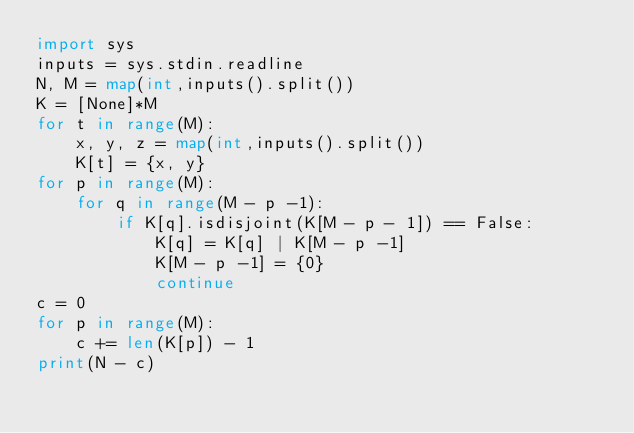<code> <loc_0><loc_0><loc_500><loc_500><_Python_>import sys
inputs = sys.stdin.readline
N, M = map(int,inputs().split())
K = [None]*M
for t in range(M):
	x, y, z = map(int,inputs().split())
	K[t] = {x, y}
for p in range(M):
	for q in range(M - p -1):
		if K[q].isdisjoint(K[M - p - 1]) == False:
			K[q] = K[q] | K[M - p -1]
			K[M - p -1] = {0}
			continue
c = 0
for p in range(M):
	c += len(K[p]) - 1
print(N - c)</code> 